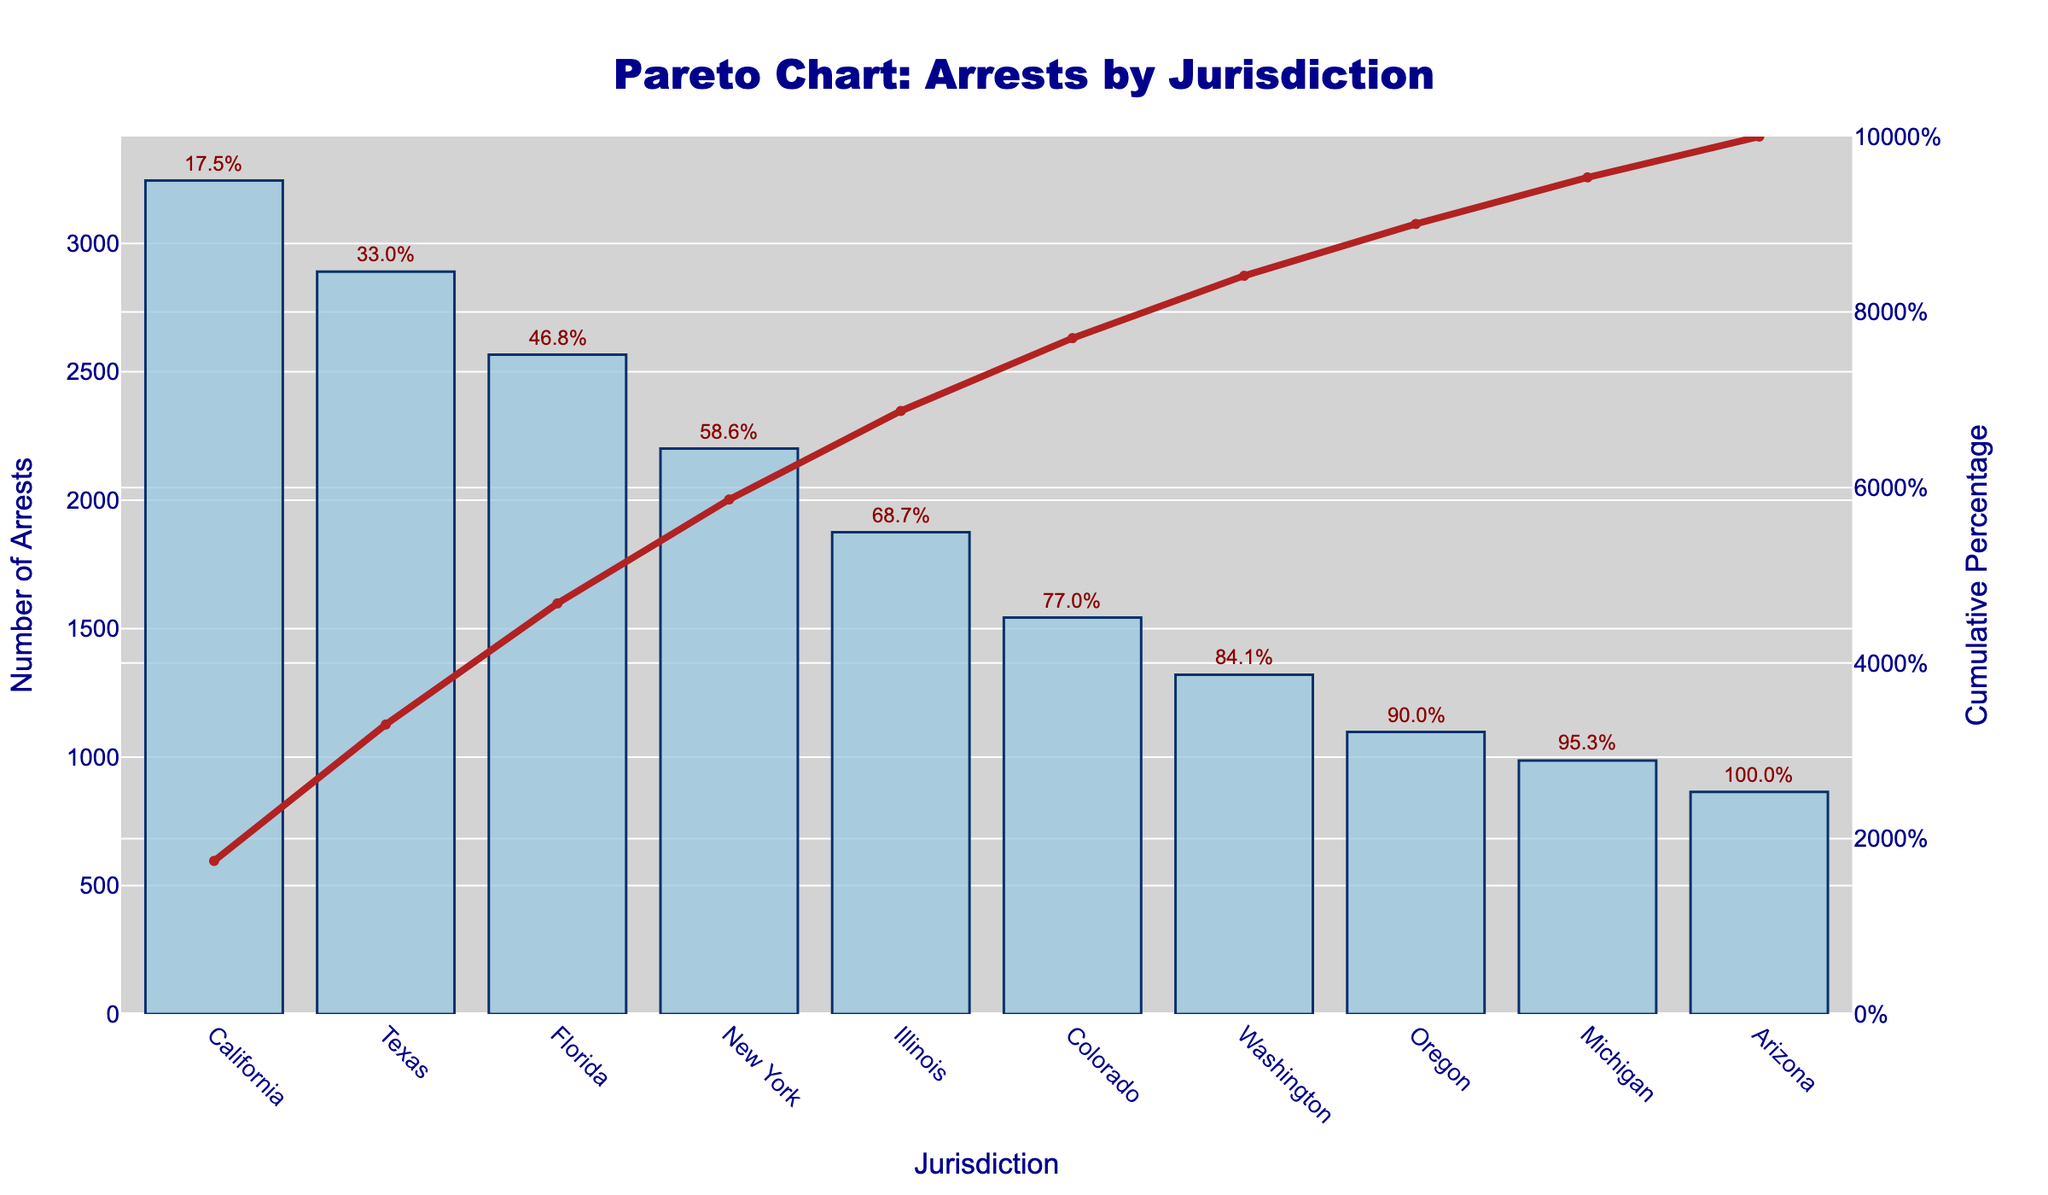What's the title of the chart? The title is usually displayed prominently at the top of the chart. It helps in understanding what the chart represents.
Answer: Pareto Chart: Arrests by Jurisdiction Which jurisdiction has the highest number of arrests? The Pareto chart has the jurisdictions on the x-axis and the number of arrests on the y-axis. The highest bar represents the jurisdiction with the most arrests.
Answer: California What is the cumulative percentage for California? The cumulative percentage can be found on the secondary y-axis (right side) for each jurisdiction. For California, it's the first jurisdiction on the left.
Answer: Approximately 13.1% How many jurisdictions are represented in the chart? The number of bars on the x-axis corresponds to the number of jurisdictions represented in the chart.
Answer: 10 Which state has fewer arrests: Washington or Oregon? By comparing the height of the bars for Washington and Oregon, the shorter bar will represent fewer arrests.
Answer: Oregon What's the cumulative percentage after the first three jurisdictions? Add the cumulative percentages of California, Texas, and Florida, as displayed on the secondary y-axis.
Answer: Approximately 39.4% What’s the difference in the number of arrests between Michigan and Arizona? Subtract the number of arrests in Arizona from the number of arrests in Michigan.
Answer: 122 Which two jurisdictions combined account for the majority of arrests? The majority implies more than 50%. Add the cumulative percentages from the left until it exceeds 50%. The first two jurisdictions, California and Texas, will be checked.
Answer: California and Texas What percent of total arrests is attributable to New York? Use the y-axis to find the number of arrests for New York and divide it by the total number of arrests, then multiply by 100.
Answer: Approximately 9.9% What’s the arrest count difference between the state with the most arrests and the state with the least arrests? Subtract the number of arrests in the lowest bar (Arizona) from the highest bar (California).
Answer: 2380 